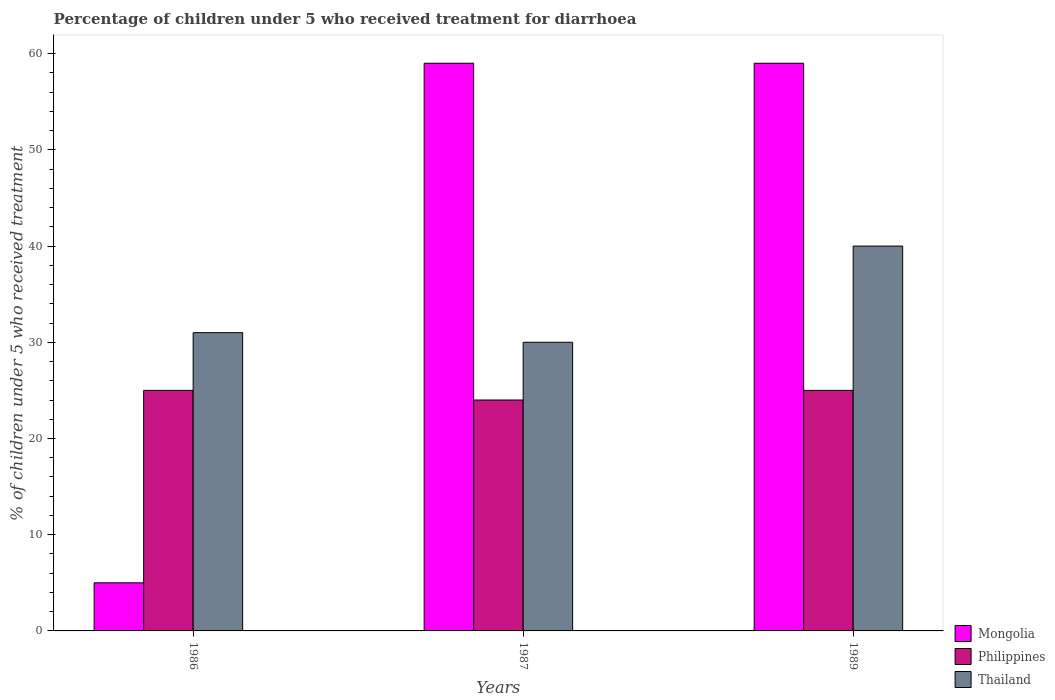How many different coloured bars are there?
Provide a succinct answer. 3. How many groups of bars are there?
Keep it short and to the point. 3. Are the number of bars per tick equal to the number of legend labels?
Your answer should be very brief. Yes. Are the number of bars on each tick of the X-axis equal?
Keep it short and to the point. Yes. How many bars are there on the 2nd tick from the left?
Your response must be concise. 3. How many bars are there on the 3rd tick from the right?
Keep it short and to the point. 3. Across all years, what is the maximum percentage of children who received treatment for diarrhoea  in Thailand?
Ensure brevity in your answer.  40. In which year was the percentage of children who received treatment for diarrhoea  in Thailand minimum?
Offer a very short reply. 1987. What is the total percentage of children who received treatment for diarrhoea  in Thailand in the graph?
Keep it short and to the point. 101. What is the difference between the percentage of children who received treatment for diarrhoea  in Philippines in 1986 and that in 1987?
Your answer should be very brief. 1. What is the difference between the percentage of children who received treatment for diarrhoea  in Philippines in 1987 and the percentage of children who received treatment for diarrhoea  in Mongolia in 1989?
Provide a succinct answer. -35. What is the average percentage of children who received treatment for diarrhoea  in Thailand per year?
Offer a very short reply. 33.67. What is the ratio of the percentage of children who received treatment for diarrhoea  in Philippines in 1986 to that in 1987?
Provide a succinct answer. 1.04. Is the difference between the percentage of children who received treatment for diarrhoea  in Mongolia in 1986 and 1987 greater than the difference between the percentage of children who received treatment for diarrhoea  in Philippines in 1986 and 1987?
Offer a very short reply. No. What is the difference between the highest and the second highest percentage of children who received treatment for diarrhoea  in Thailand?
Provide a short and direct response. 9. What is the difference between the highest and the lowest percentage of children who received treatment for diarrhoea  in Mongolia?
Keep it short and to the point. 54. In how many years, is the percentage of children who received treatment for diarrhoea  in Mongolia greater than the average percentage of children who received treatment for diarrhoea  in Mongolia taken over all years?
Provide a succinct answer. 2. What does the 1st bar from the left in 1989 represents?
Ensure brevity in your answer.  Mongolia. What does the 3rd bar from the right in 1987 represents?
Your answer should be compact. Mongolia. How many bars are there?
Make the answer very short. 9. Are all the bars in the graph horizontal?
Make the answer very short. No. Does the graph contain grids?
Make the answer very short. No. Where does the legend appear in the graph?
Give a very brief answer. Bottom right. How are the legend labels stacked?
Provide a short and direct response. Vertical. What is the title of the graph?
Provide a succinct answer. Percentage of children under 5 who received treatment for diarrhoea. Does "World" appear as one of the legend labels in the graph?
Keep it short and to the point. No. What is the label or title of the Y-axis?
Keep it short and to the point. % of children under 5 who received treatment. What is the % of children under 5 who received treatment of Mongolia in 1986?
Offer a very short reply. 5. What is the % of children under 5 who received treatment of Philippines in 1986?
Make the answer very short. 25. What is the % of children under 5 who received treatment in Philippines in 1987?
Give a very brief answer. 24. What is the % of children under 5 who received treatment in Thailand in 1987?
Give a very brief answer. 30. What is the % of children under 5 who received treatment in Philippines in 1989?
Your response must be concise. 25. Across all years, what is the minimum % of children under 5 who received treatment in Mongolia?
Ensure brevity in your answer.  5. What is the total % of children under 5 who received treatment of Mongolia in the graph?
Keep it short and to the point. 123. What is the total % of children under 5 who received treatment in Thailand in the graph?
Your response must be concise. 101. What is the difference between the % of children under 5 who received treatment of Mongolia in 1986 and that in 1987?
Your answer should be compact. -54. What is the difference between the % of children under 5 who received treatment of Philippines in 1986 and that in 1987?
Give a very brief answer. 1. What is the difference between the % of children under 5 who received treatment in Thailand in 1986 and that in 1987?
Make the answer very short. 1. What is the difference between the % of children under 5 who received treatment of Mongolia in 1986 and that in 1989?
Ensure brevity in your answer.  -54. What is the difference between the % of children under 5 who received treatment of Philippines in 1986 and that in 1989?
Offer a terse response. 0. What is the difference between the % of children under 5 who received treatment in Thailand in 1986 and that in 1989?
Give a very brief answer. -9. What is the difference between the % of children under 5 who received treatment of Mongolia in 1986 and the % of children under 5 who received treatment of Philippines in 1987?
Provide a succinct answer. -19. What is the difference between the % of children under 5 who received treatment of Mongolia in 1986 and the % of children under 5 who received treatment of Thailand in 1989?
Give a very brief answer. -35. What is the difference between the % of children under 5 who received treatment in Mongolia in 1987 and the % of children under 5 who received treatment in Philippines in 1989?
Keep it short and to the point. 34. What is the difference between the % of children under 5 who received treatment of Philippines in 1987 and the % of children under 5 who received treatment of Thailand in 1989?
Provide a succinct answer. -16. What is the average % of children under 5 who received treatment of Mongolia per year?
Your answer should be very brief. 41. What is the average % of children under 5 who received treatment of Philippines per year?
Keep it short and to the point. 24.67. What is the average % of children under 5 who received treatment of Thailand per year?
Provide a succinct answer. 33.67. In the year 1986, what is the difference between the % of children under 5 who received treatment in Mongolia and % of children under 5 who received treatment in Thailand?
Make the answer very short. -26. In the year 1987, what is the difference between the % of children under 5 who received treatment in Mongolia and % of children under 5 who received treatment in Philippines?
Keep it short and to the point. 35. In the year 1987, what is the difference between the % of children under 5 who received treatment in Mongolia and % of children under 5 who received treatment in Thailand?
Ensure brevity in your answer.  29. In the year 1989, what is the difference between the % of children under 5 who received treatment of Mongolia and % of children under 5 who received treatment of Thailand?
Provide a short and direct response. 19. What is the ratio of the % of children under 5 who received treatment in Mongolia in 1986 to that in 1987?
Keep it short and to the point. 0.08. What is the ratio of the % of children under 5 who received treatment of Philippines in 1986 to that in 1987?
Offer a very short reply. 1.04. What is the ratio of the % of children under 5 who received treatment in Mongolia in 1986 to that in 1989?
Ensure brevity in your answer.  0.08. What is the ratio of the % of children under 5 who received treatment in Philippines in 1986 to that in 1989?
Provide a short and direct response. 1. What is the ratio of the % of children under 5 who received treatment of Thailand in 1986 to that in 1989?
Offer a very short reply. 0.78. What is the ratio of the % of children under 5 who received treatment in Philippines in 1987 to that in 1989?
Offer a terse response. 0.96. What is the difference between the highest and the second highest % of children under 5 who received treatment in Mongolia?
Make the answer very short. 0. What is the difference between the highest and the second highest % of children under 5 who received treatment of Thailand?
Provide a succinct answer. 9. What is the difference between the highest and the lowest % of children under 5 who received treatment of Mongolia?
Your response must be concise. 54. What is the difference between the highest and the lowest % of children under 5 who received treatment of Philippines?
Offer a terse response. 1. 